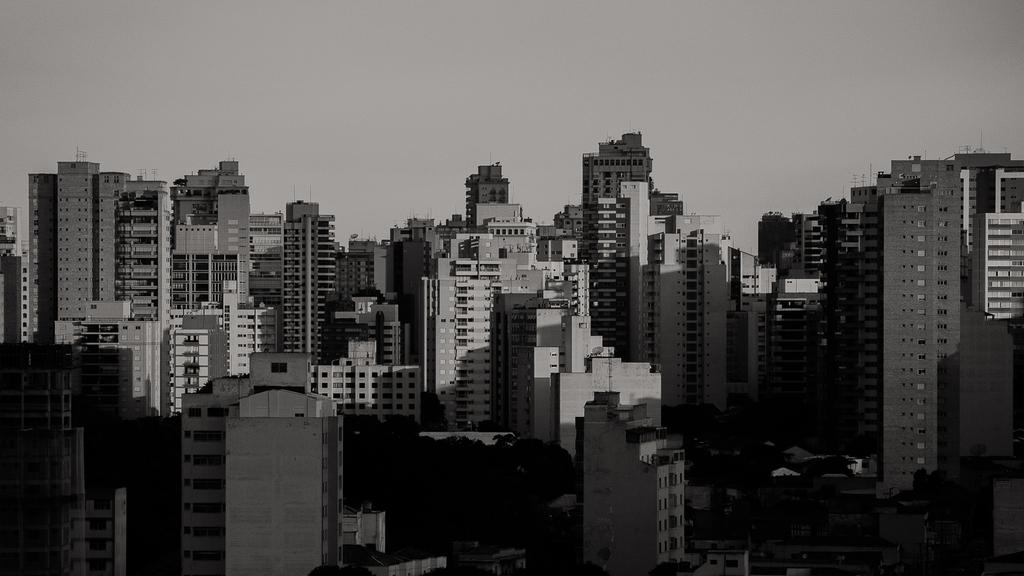What is the color scheme of the image? The image is black and white. What type of structures can be seen in the image? There are buildings in the image. What other elements are present in the image besides buildings? There are trees in the image. What can be seen in the background of the image? The sky is visible in the background of the image. What type of sock is hanging on the tree in the image? There is no sock present in the image; it is a black and white image featuring buildings, trees, and a visible sky. 